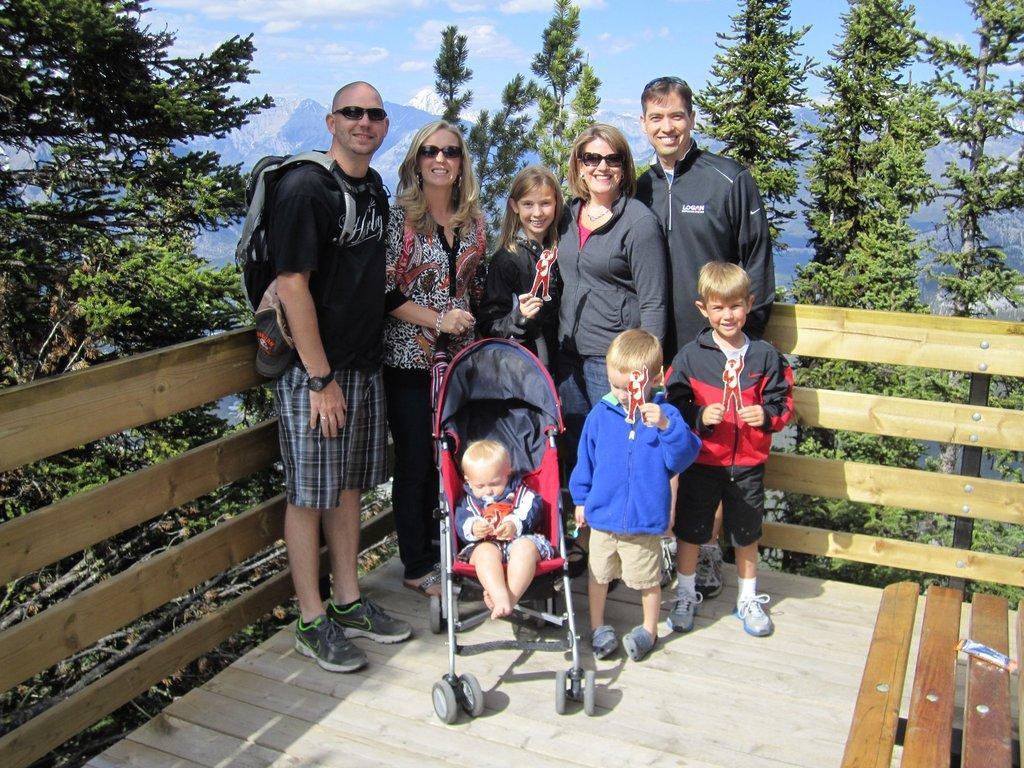Please provide a concise description of this image. In the center of the picture there is a family, a kid is in the cart. On the right there is a bench. In the center of the picture there are trees. In the background there are mountains. 